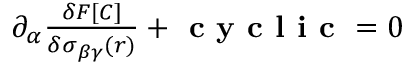Convert formula to latex. <formula><loc_0><loc_0><loc_500><loc_500>\begin{array} { r } { \partial _ { \alpha } \frac { \delta F [ C ] } { \delta \sigma _ { \beta \gamma } ( r ) } + c y c l i c = 0 } \end{array}</formula> 